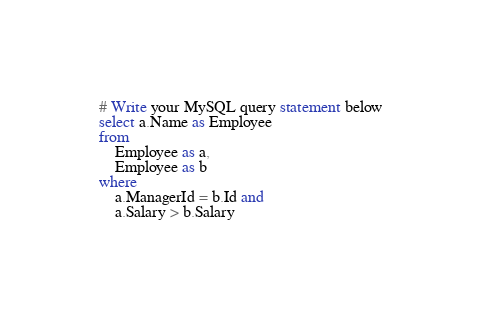Convert code to text. <code><loc_0><loc_0><loc_500><loc_500><_SQL_>
# Write your MySQL query statement below
select a.Name as Employee
from
    Employee as a,
    Employee as b
where 
    a.ManagerId = b.Id and
    a.Salary > b.Salary</code> 